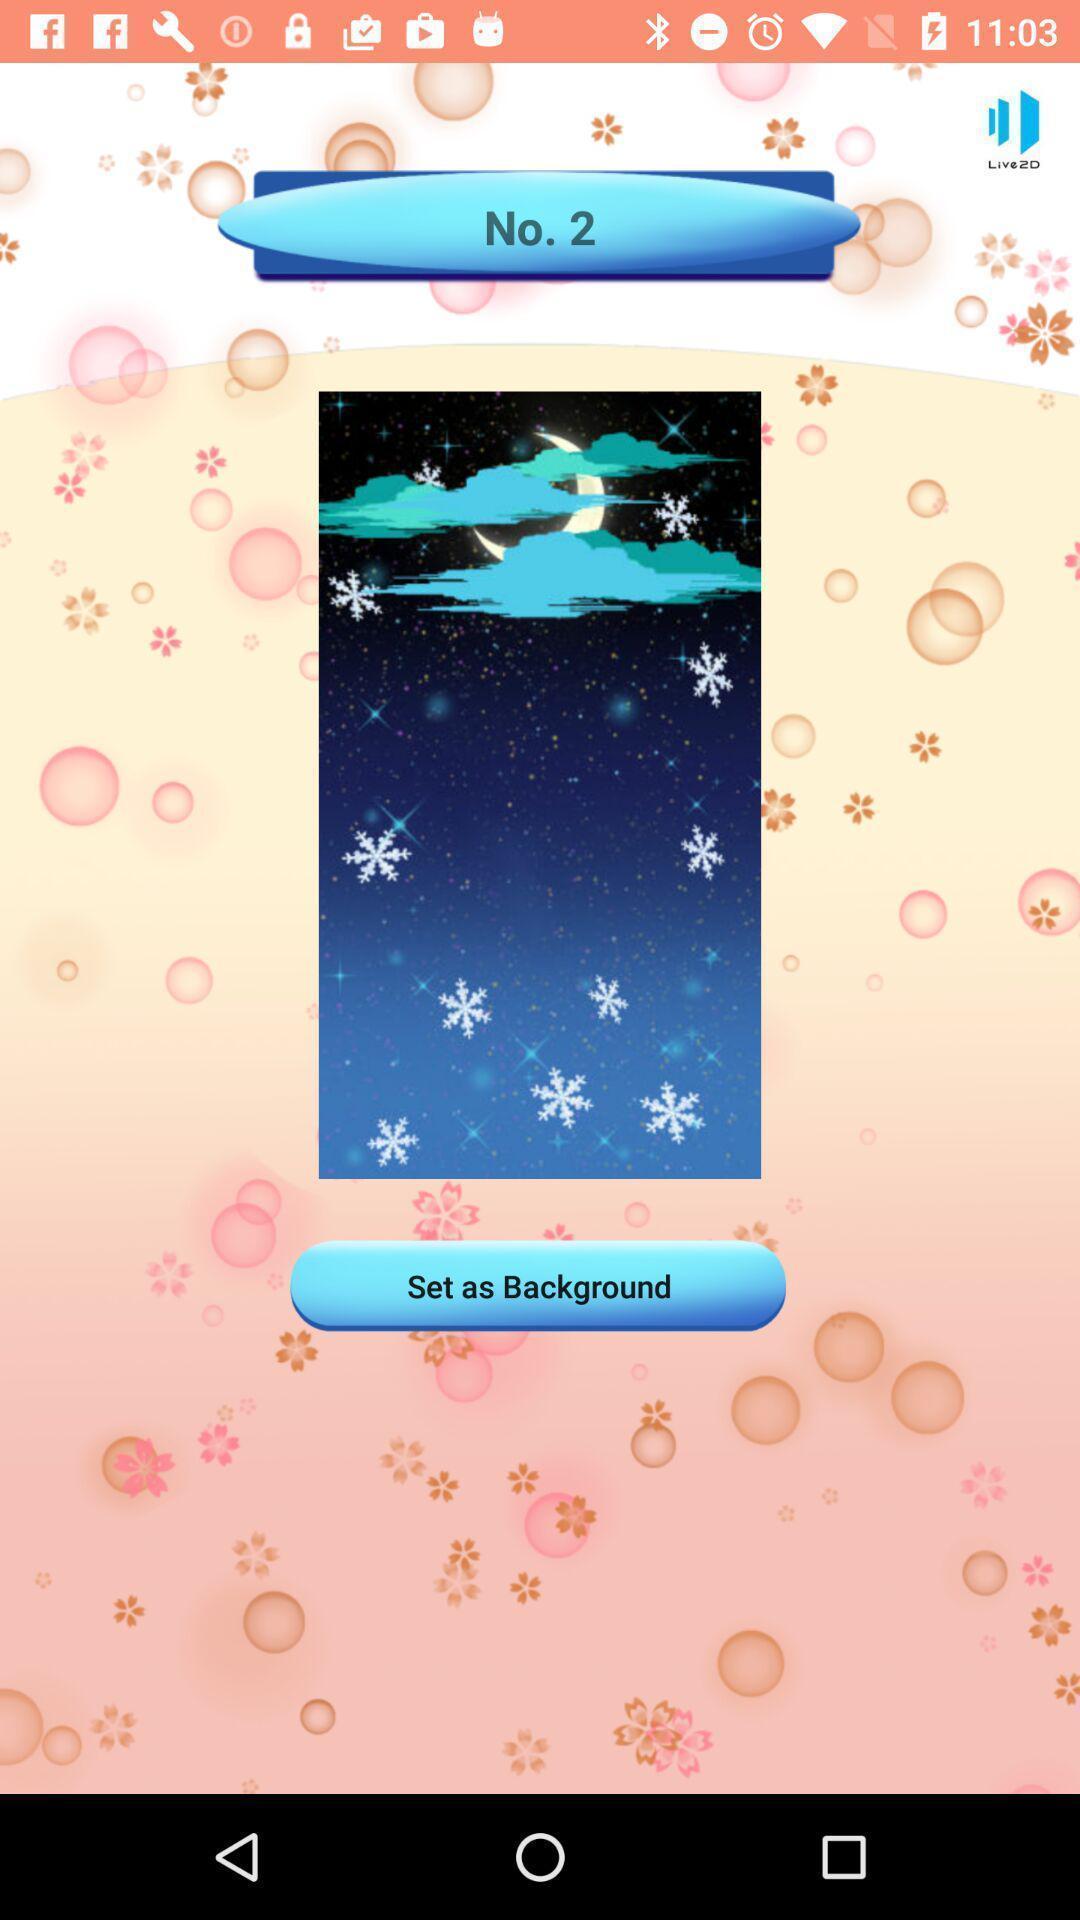What details can you identify in this image? Social app for selecting background. 